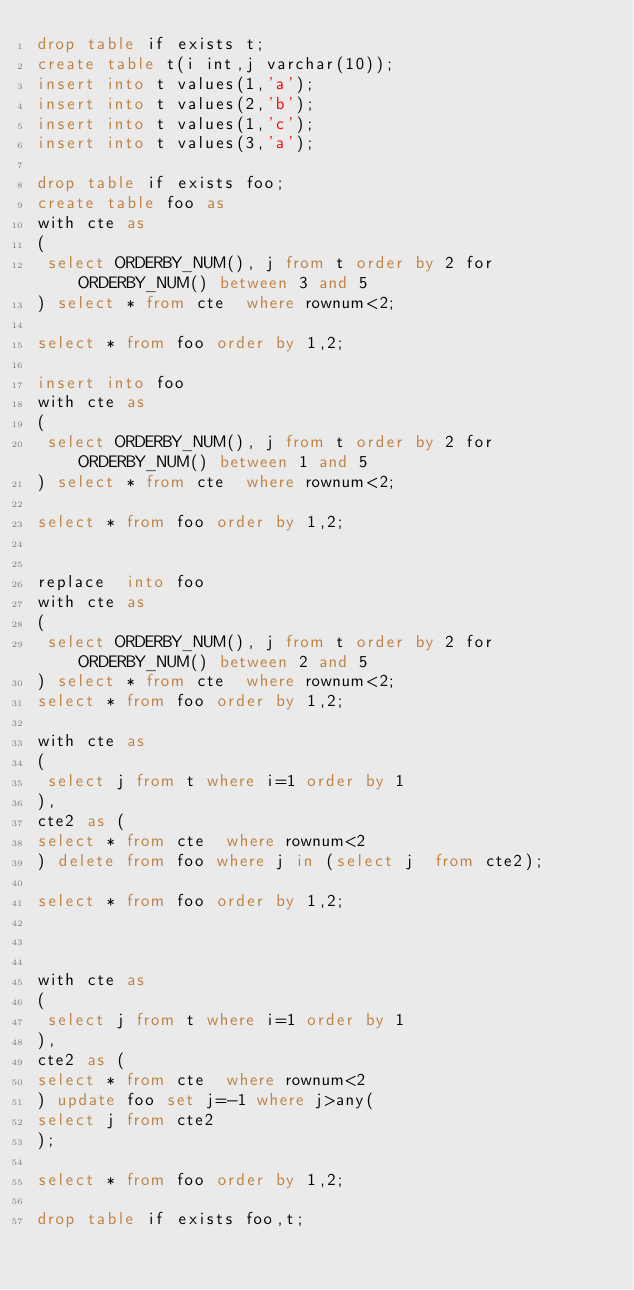Convert code to text. <code><loc_0><loc_0><loc_500><loc_500><_SQL_>drop table if exists t;
create table t(i int,j varchar(10));
insert into t values(1,'a');
insert into t values(2,'b');
insert into t values(1,'c');
insert into t values(3,'a');

drop table if exists foo;
create table foo as
with cte as
(
 select ORDERBY_NUM(), j from t order by 2 for ORDERBY_NUM() between 3 and 5
) select * from cte  where rownum<2;

select * from foo order by 1,2;

insert into foo
with cte as
(
 select ORDERBY_NUM(), j from t order by 2 for ORDERBY_NUM() between 1 and 5
) select * from cte  where rownum<2;

select * from foo order by 1,2;


replace  into foo
with cte as
(
 select ORDERBY_NUM(), j from t order by 2 for ORDERBY_NUM() between 2 and 5
) select * from cte  where rownum<2;
select * from foo order by 1,2;

with cte as
(
 select j from t where i=1 order by 1
),
cte2 as (
select * from cte  where rownum<2
) delete from foo where j in (select j  from cte2);

select * from foo order by 1,2;



with cte as
(
 select j from t where i=1 order by 1
),
cte2 as (
select * from cte  where rownum<2
) update foo set j=-1 where j>any(
select j from cte2
);

select * from foo order by 1,2;

drop table if exists foo,t;
</code> 